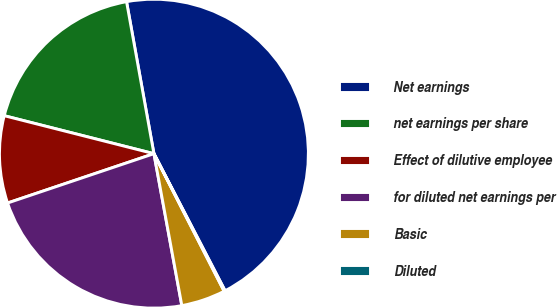Convert chart. <chart><loc_0><loc_0><loc_500><loc_500><pie_chart><fcel>Net earnings<fcel>net earnings per share<fcel>Effect of dilutive employee<fcel>for diluted net earnings per<fcel>Basic<fcel>Diluted<nl><fcel>45.22%<fcel>18.21%<fcel>9.13%<fcel>22.72%<fcel>4.62%<fcel>0.11%<nl></chart> 